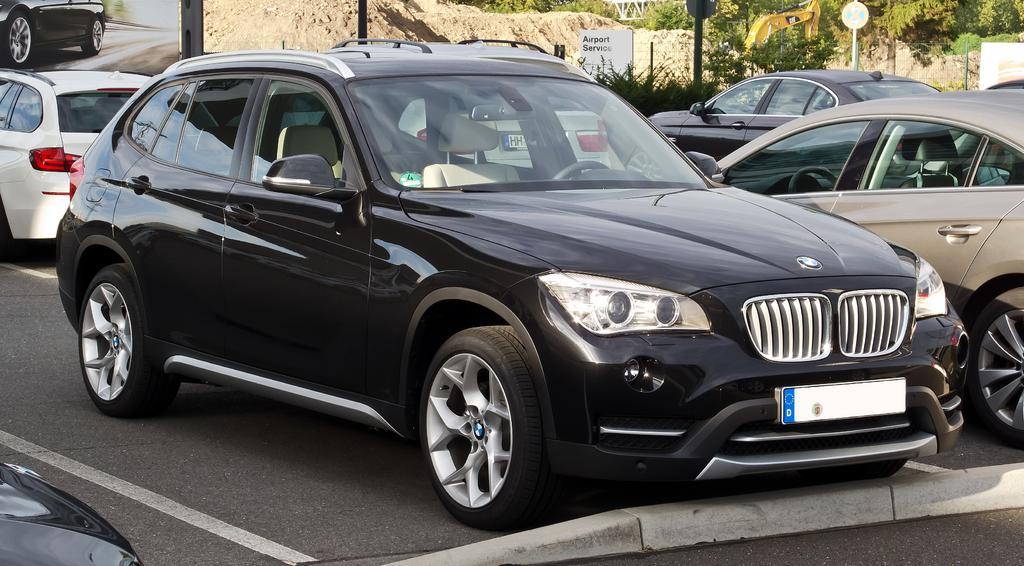In one or two sentences, can you explain what this image depicts? In this image there are cars and we can see trees. There are boards. At the bottom we can see a road. 